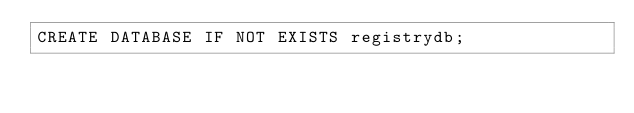Convert code to text. <code><loc_0><loc_0><loc_500><loc_500><_SQL_>CREATE DATABASE IF NOT EXISTS registrydb;
</code> 